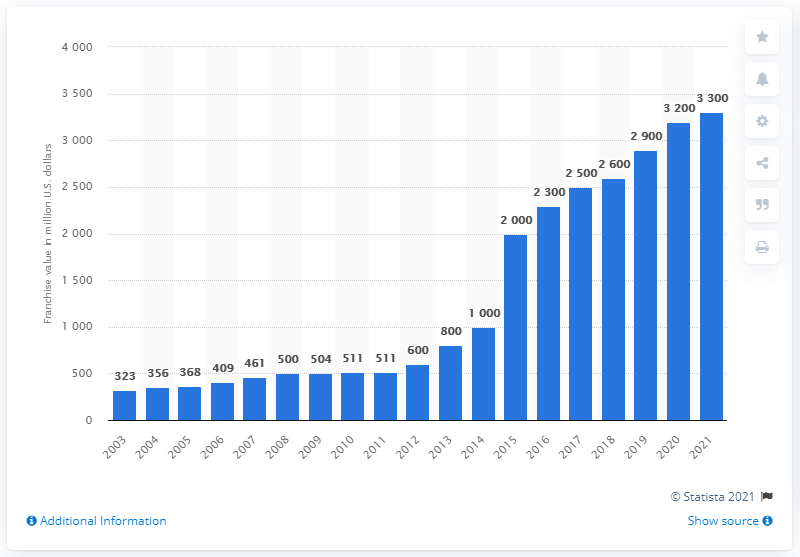Can you provide an analysis of the trend in the franchise value of the Chicago Bulls over the past years, as shown in this chart? Certainly! The chart displays a consistent upward trend in the franchise value of the Chicago Bulls from 2003 to 2021. Starting at $323 million in 2003, there's a notable increase nearly every year, reflecting a range of factors such as team performance, brand development, inflation, and changes in revenue due to broadcasting and endorsements. By 2021, the value had reached $3.3 billion, illustrating significant growth over the period. 